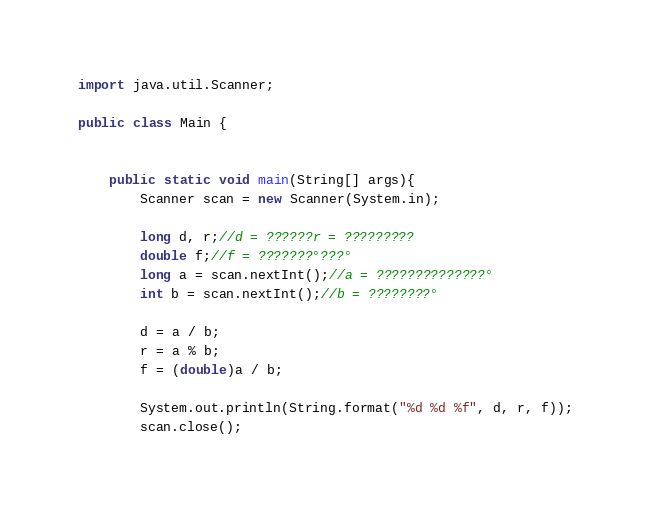<code> <loc_0><loc_0><loc_500><loc_500><_Java_>import java.util.Scanner;

public class Main {


    public static void main(String[] args){
		Scanner scan = new Scanner(System.in);

		long d, r;//d = ??????r = ?????????
		double f;//f = ???????°???°
		long a = scan.nextInt();//a = ??????????????°
		int b = scan.nextInt();//b = ????????°

		d = a / b;
		r = a % b;
		f = (double)a / b;

		System.out.println(String.format("%d %d %f", d, r, f));
        scan.close();</code> 